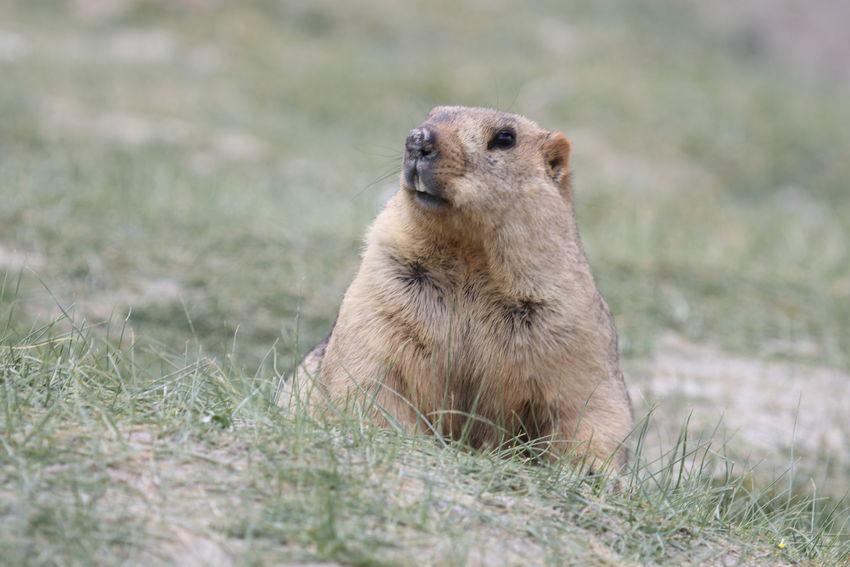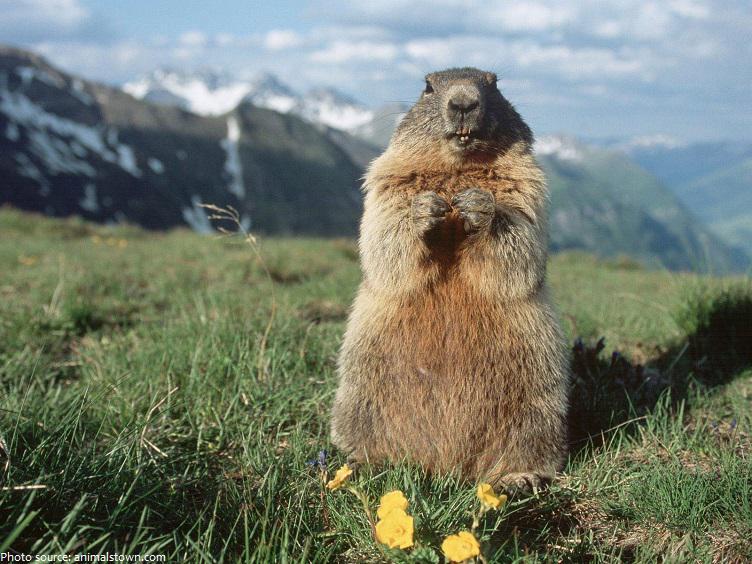The first image is the image on the left, the second image is the image on the right. Given the left and right images, does the statement "The right image contains at least two rodents." hold true? Answer yes or no. No. The first image is the image on the left, the second image is the image on the right. Given the left and right images, does the statement "We've got three groundhogs here." hold true? Answer yes or no. No. 